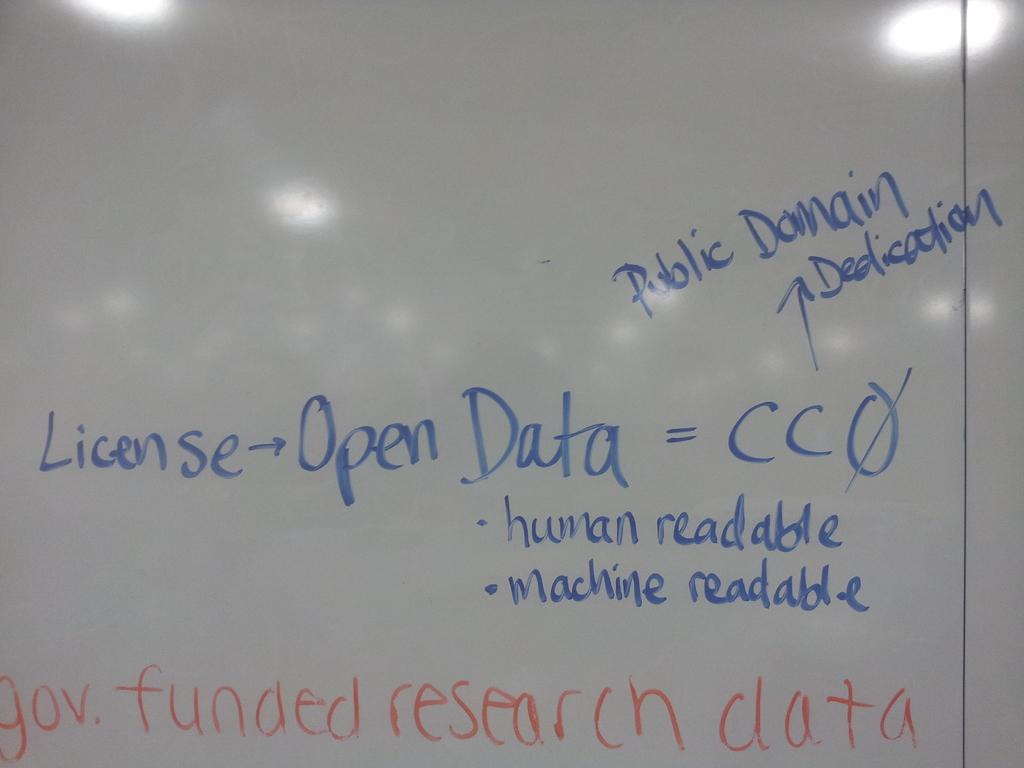<image>
Provide a brief description of the given image. White board that have information on a government research data 